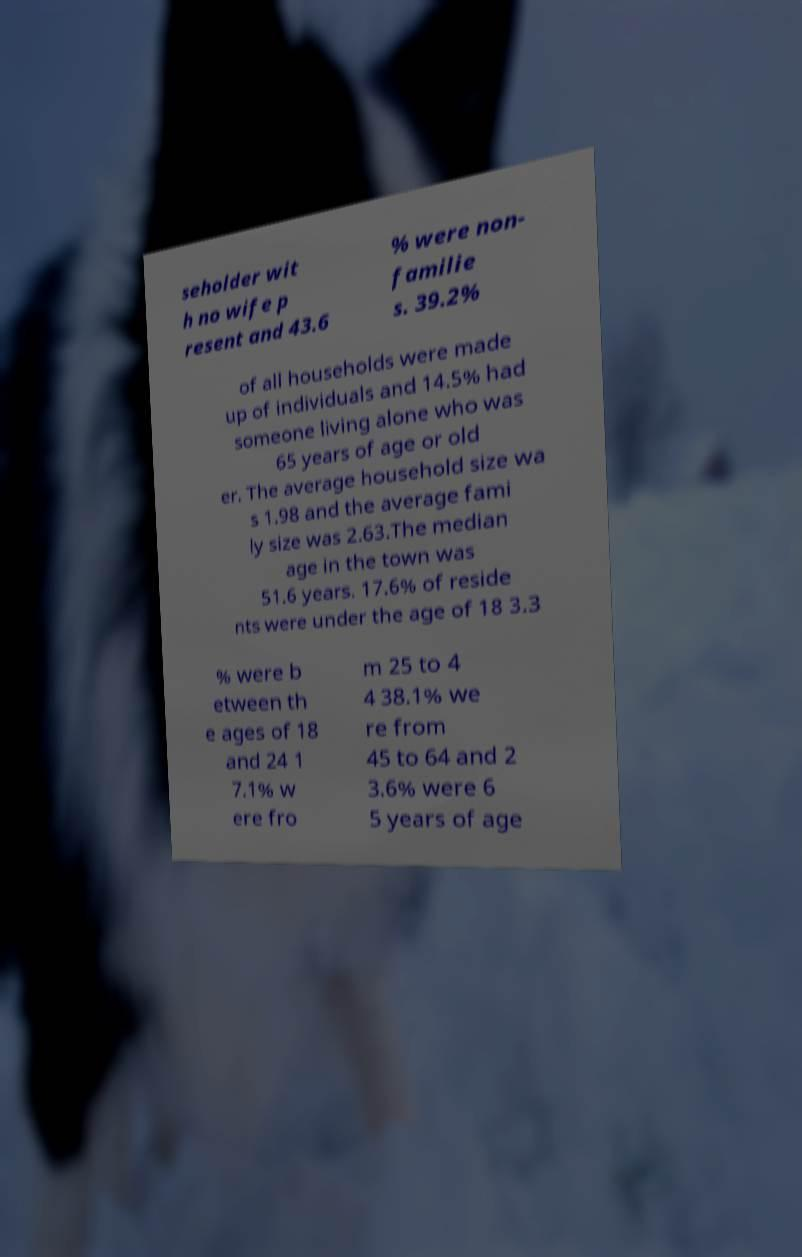Please read and relay the text visible in this image. What does it say? seholder wit h no wife p resent and 43.6 % were non- familie s. 39.2% of all households were made up of individuals and 14.5% had someone living alone who was 65 years of age or old er. The average household size wa s 1.98 and the average fami ly size was 2.63.The median age in the town was 51.6 years. 17.6% of reside nts were under the age of 18 3.3 % were b etween th e ages of 18 and 24 1 7.1% w ere fro m 25 to 4 4 38.1% we re from 45 to 64 and 2 3.6% were 6 5 years of age 